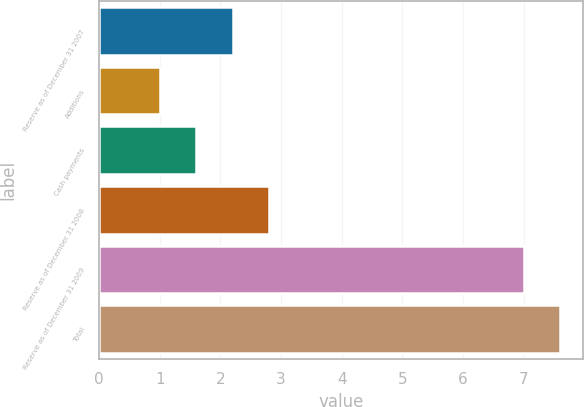Convert chart. <chart><loc_0><loc_0><loc_500><loc_500><bar_chart><fcel>Reserve as of December 31 2007<fcel>Additions<fcel>Cash payments<fcel>Reserve as of December 31 2008<fcel>Reserve as of December 31 2009<fcel>Total<nl><fcel>2.2<fcel>1<fcel>1.6<fcel>2.8<fcel>7<fcel>7.6<nl></chart> 